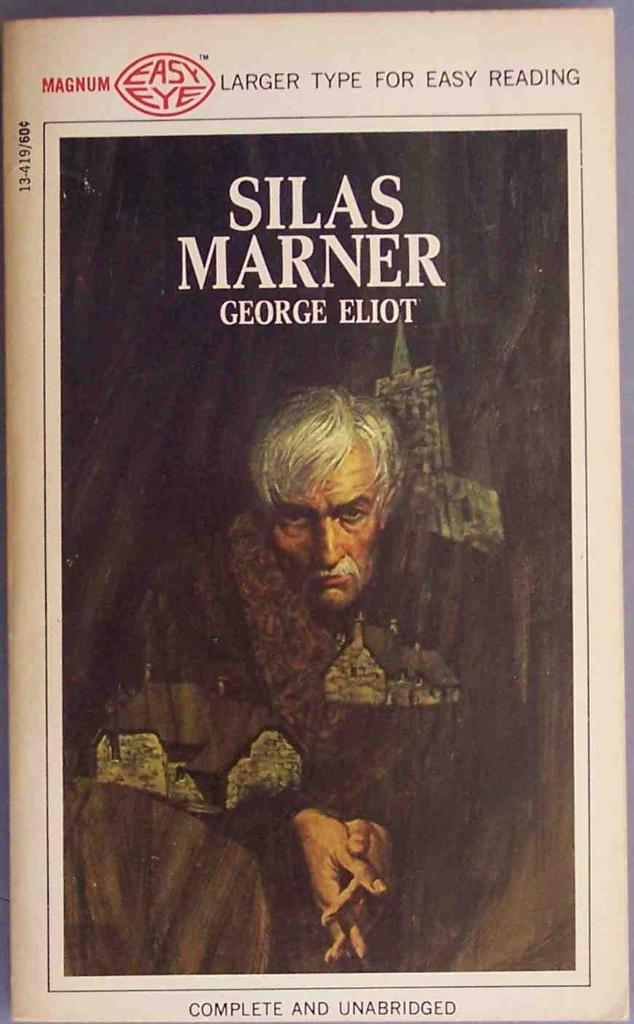<image>
Share a concise interpretation of the image provided. The complete and unabridged book Silas Marner is printed with larger type for easy reading. 